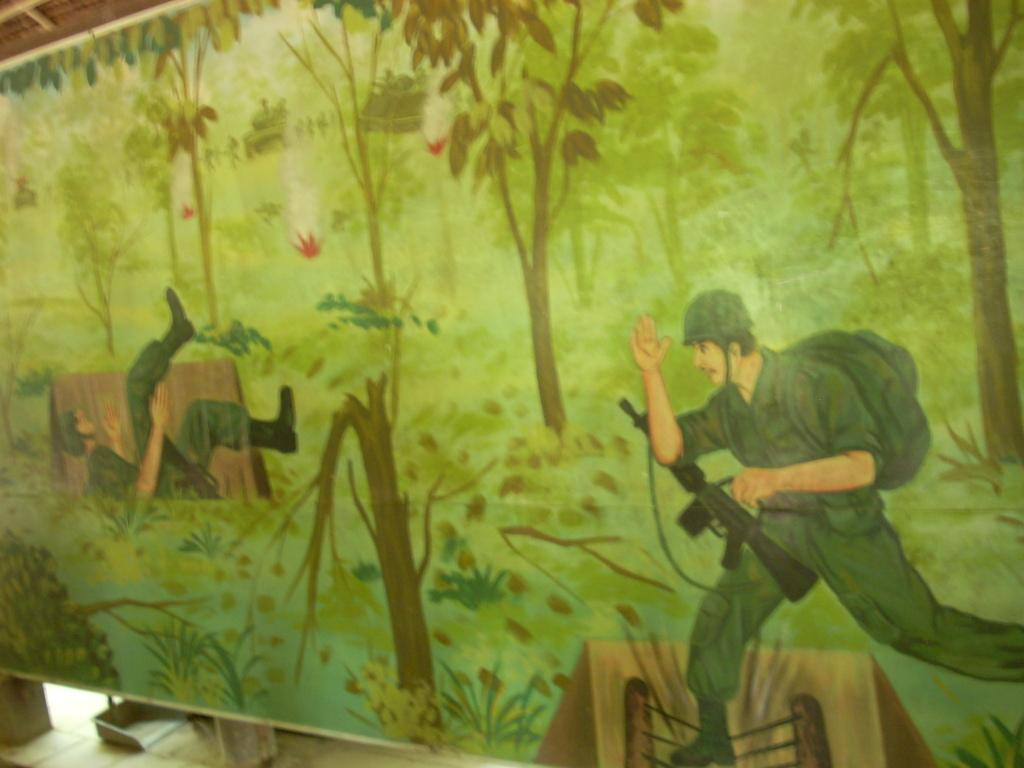What is the main object in the image? There is a board in the image. What is depicted on the board? The board contains an art piece. What elements are included in the art piece? The art piece includes images of people, trees, and a house. What is visible at the bottom of the image? There is a floor visible at the bottom of the image. What type of advertisement can be seen on the board in the image? There is no advertisement present on the board in the image; it contains an art piece. How many balls are included in the art piece on the board? There are no balls included in the art piece on the board; it features images of people, trees, and a house. 